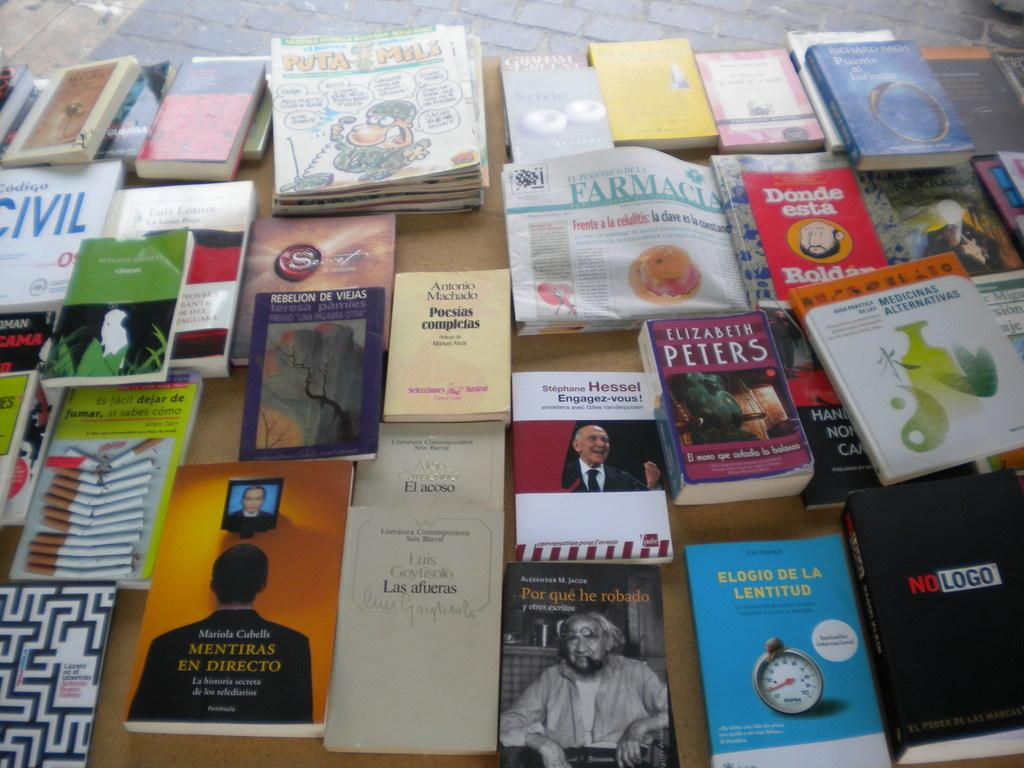<image>
Describe the image concisely. A book titled Mentira en Directo sits on a table covered with books. 